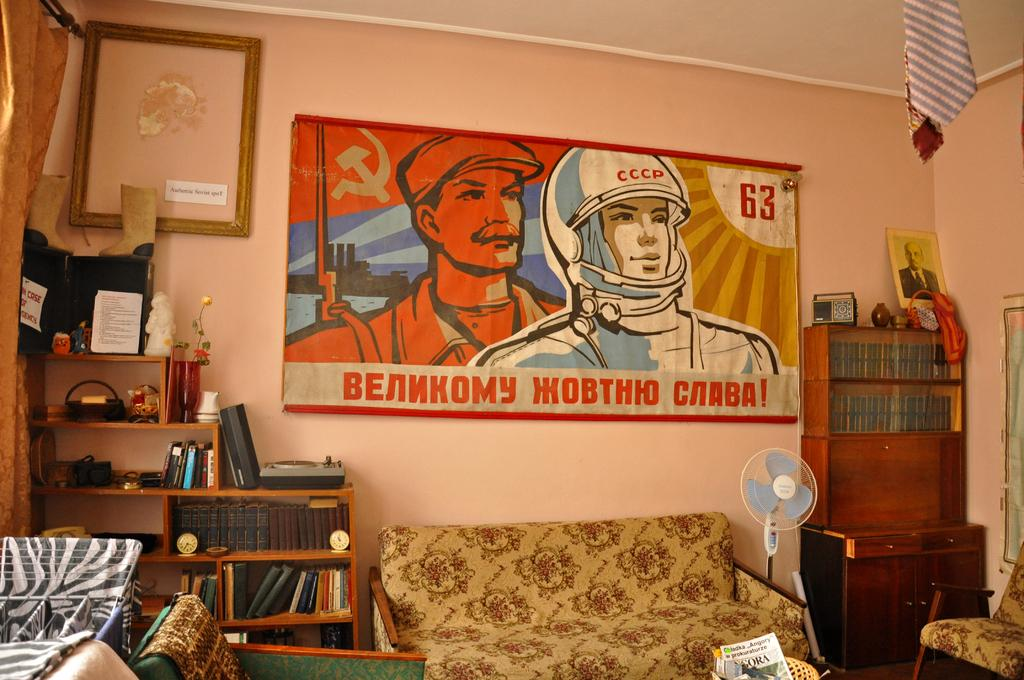What type of furniture is present in the room? There is a sofa and a cupboard in the room. What can be found on the racks in the room? The racks in the room have books on them. What decorative item is present in the room? There is a flower vase in the room. What is hanging on the wall in the room? There is a frame on the wall in the room. What is inside the frame? There is a photo in the room. What type of clothing item is hanging in the room? There is a tie hanging in the room. How many plants are present in the room? There is no information about plants in the room, so we cannot determine the number of plants. What is the digestive system of the spiders in the room? There are no spiders mentioned in the room, so we cannot discuss their digestive system. 